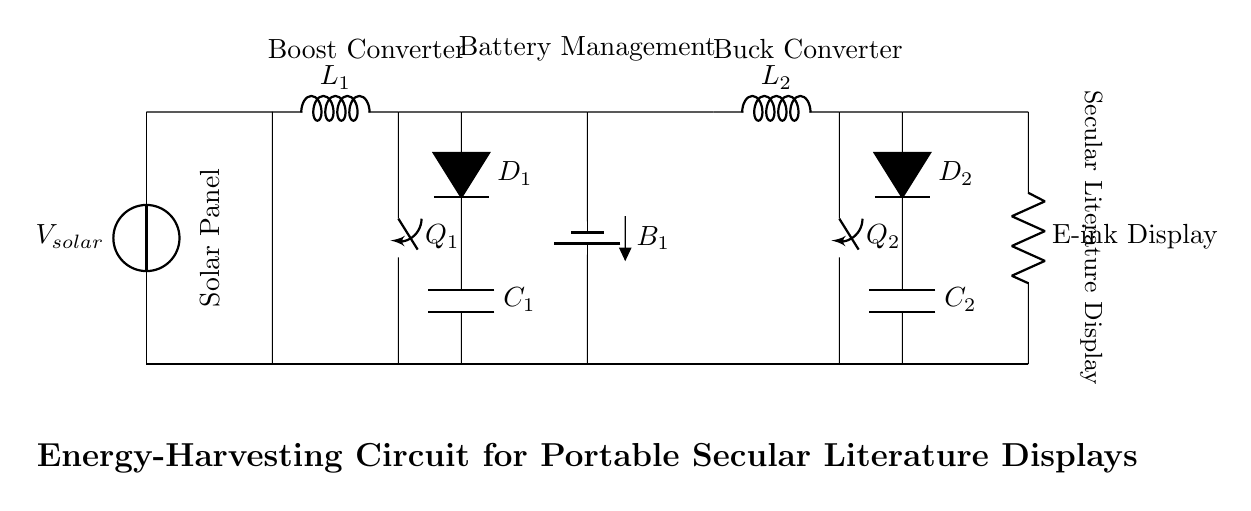What is the function of the solar panel? The solar panel converts solar energy into electrical energy, providing the initial power source for the circuit.
Answer: Convert solar energy What type of converter is used after the solar panel? The circuit uses a boost converter, which steps up the voltage from the solar panel to a higher level suitable for charging the battery.
Answer: Boost converter How many capacitors are present in the circuit? There are two capacitors, labeled C1 and C2, used in the boost and buck converters respectively for energy storage and regulation.
Answer: Two What type of load is connected at the end of the circuit? The load is an E-ink display, which is a low-power display technology suitable for portable literature.
Answer: E-ink display What is the role of D1 in the circuit? D1 is a diode that prevents reverse current flow within the boost converter, ensuring that the output energy flows in the correct direction to the capacitor.
Answer: Prevent reverse current Which component manages the battery charging? The battery management system is responsible for controlling the charge and discharge processes of the battery, ensuring safe operation and longevity.
Answer: Battery management What happens in the buck converter? The buck converter steps down the voltage from the battery to a level suitable for powering the E-ink display while maintaining efficient energy use.
Answer: Step down voltage 